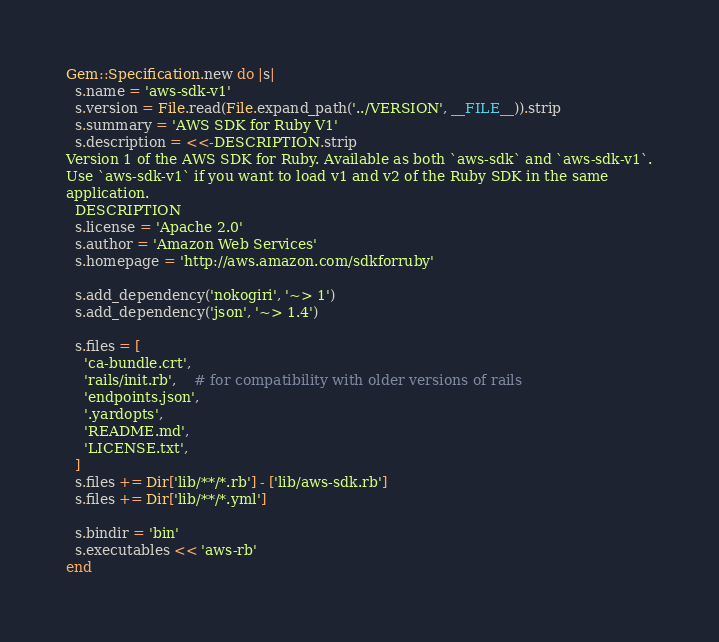Convert code to text. <code><loc_0><loc_0><loc_500><loc_500><_Ruby_>Gem::Specification.new do |s|
  s.name = 'aws-sdk-v1'
  s.version = File.read(File.expand_path('../VERSION', __FILE__)).strip
  s.summary = 'AWS SDK for Ruby V1'
  s.description = <<-DESCRIPTION.strip
Version 1 of the AWS SDK for Ruby. Available as both `aws-sdk` and `aws-sdk-v1`.
Use `aws-sdk-v1` if you want to load v1 and v2 of the Ruby SDK in the same
application.
  DESCRIPTION
  s.license = 'Apache 2.0'
  s.author = 'Amazon Web Services'
  s.homepage = 'http://aws.amazon.com/sdkforruby'

  s.add_dependency('nokogiri', '~> 1')
  s.add_dependency('json', '~> 1.4')

  s.files = [
    'ca-bundle.crt',
    'rails/init.rb',    # for compatibility with older versions of rails
    'endpoints.json',
    '.yardopts',
    'README.md',
    'LICENSE.txt',
  ]
  s.files += Dir['lib/**/*.rb'] - ['lib/aws-sdk.rb']
  s.files += Dir['lib/**/*.yml']

  s.bindir = 'bin'
  s.executables << 'aws-rb'
end
</code> 